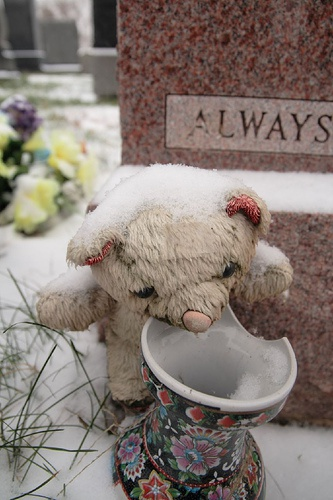Describe the objects in this image and their specific colors. I can see teddy bear in gray, lightgray, and darkgray tones and vase in gray, darkgray, black, and maroon tones in this image. 